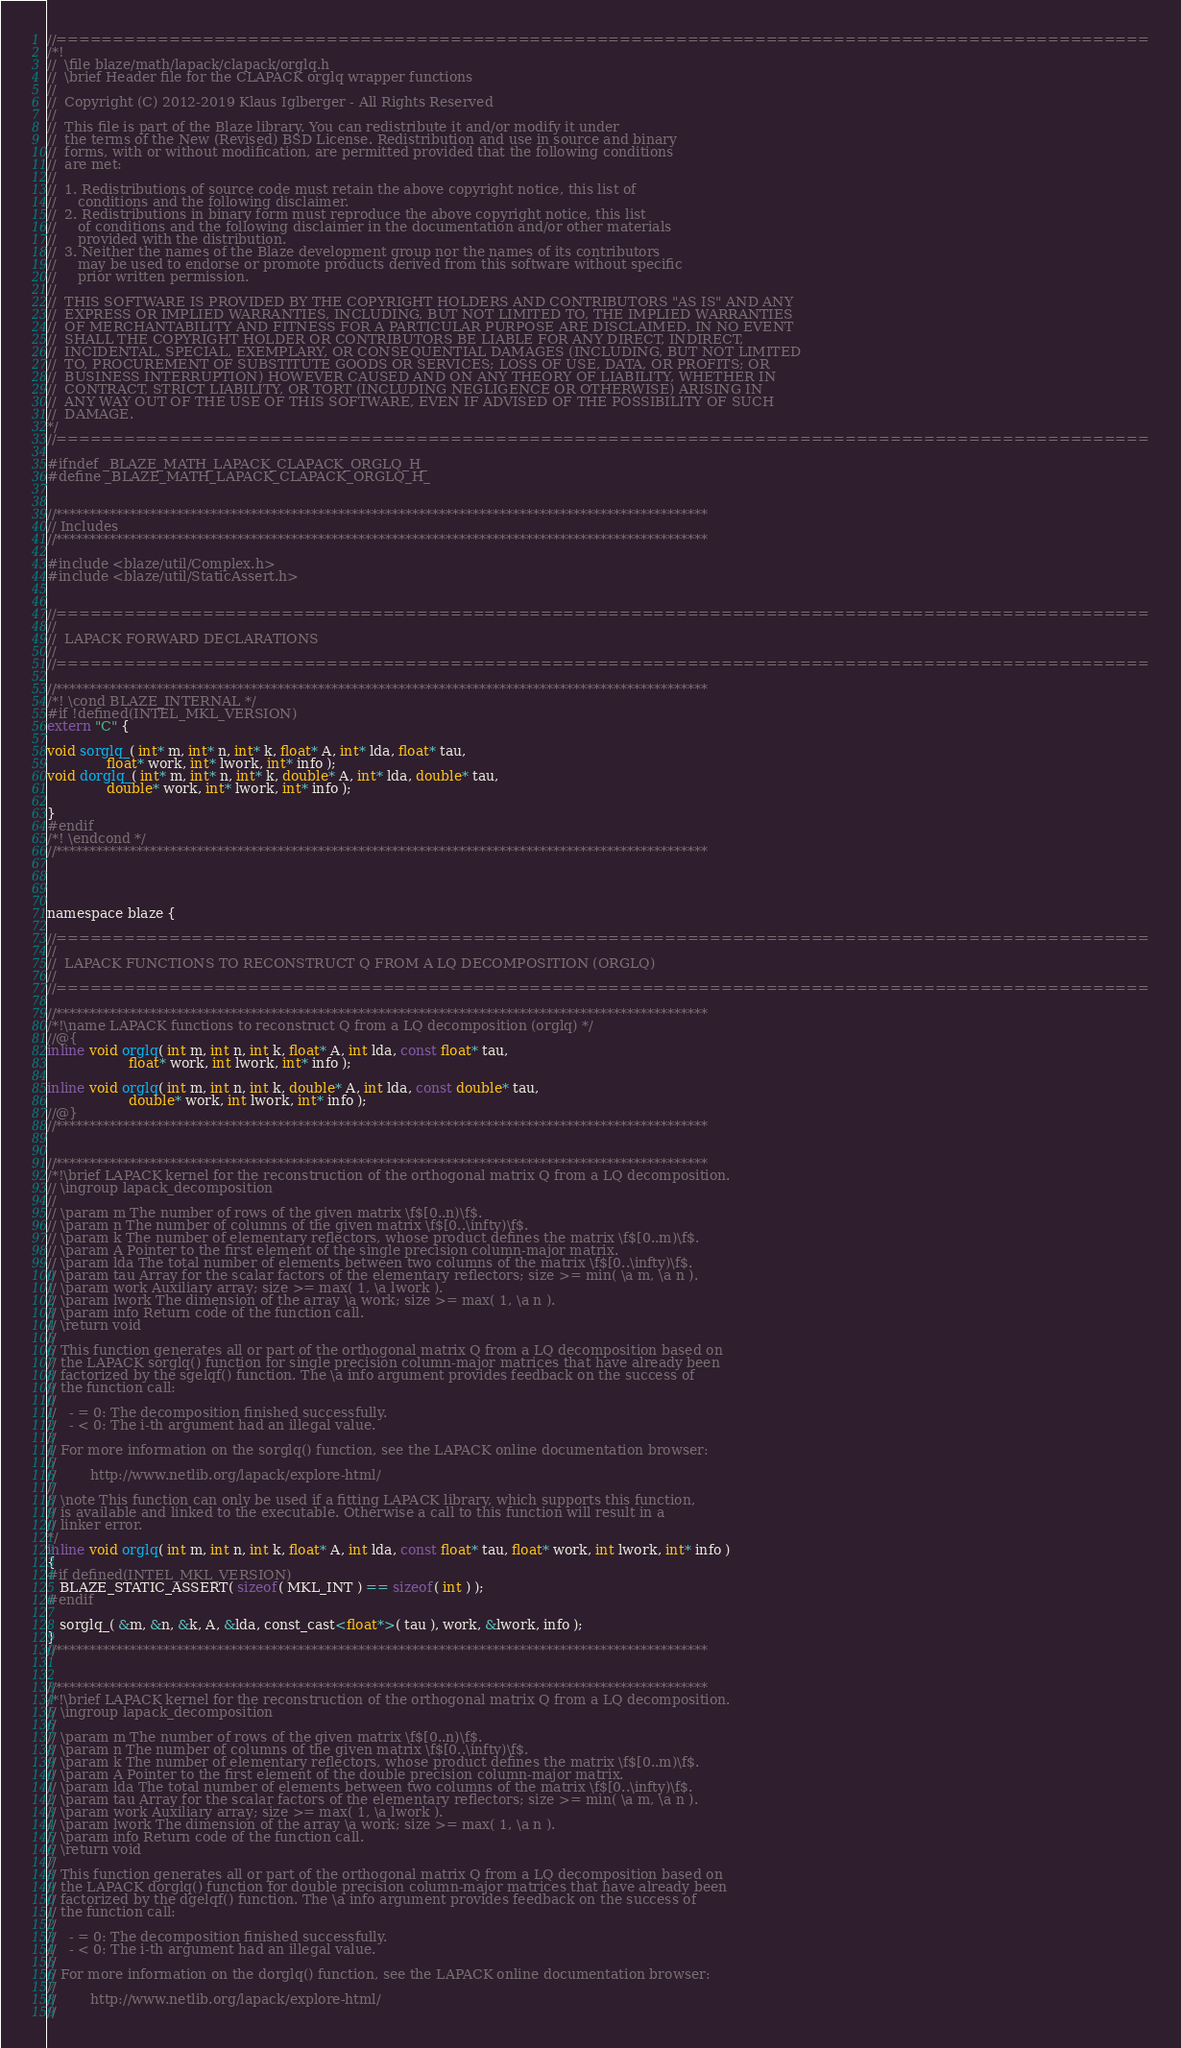<code> <loc_0><loc_0><loc_500><loc_500><_C_>//=================================================================================================
/*!
//  \file blaze/math/lapack/clapack/orglq.h
//  \brief Header file for the CLAPACK orglq wrapper functions
//
//  Copyright (C) 2012-2019 Klaus Iglberger - All Rights Reserved
//
//  This file is part of the Blaze library. You can redistribute it and/or modify it under
//  the terms of the New (Revised) BSD License. Redistribution and use in source and binary
//  forms, with or without modification, are permitted provided that the following conditions
//  are met:
//
//  1. Redistributions of source code must retain the above copyright notice, this list of
//     conditions and the following disclaimer.
//  2. Redistributions in binary form must reproduce the above copyright notice, this list
//     of conditions and the following disclaimer in the documentation and/or other materials
//     provided with the distribution.
//  3. Neither the names of the Blaze development group nor the names of its contributors
//     may be used to endorse or promote products derived from this software without specific
//     prior written permission.
//
//  THIS SOFTWARE IS PROVIDED BY THE COPYRIGHT HOLDERS AND CONTRIBUTORS "AS IS" AND ANY
//  EXPRESS OR IMPLIED WARRANTIES, INCLUDING, BUT NOT LIMITED TO, THE IMPLIED WARRANTIES
//  OF MERCHANTABILITY AND FITNESS FOR A PARTICULAR PURPOSE ARE DISCLAIMED. IN NO EVENT
//  SHALL THE COPYRIGHT HOLDER OR CONTRIBUTORS BE LIABLE FOR ANY DIRECT, INDIRECT,
//  INCIDENTAL, SPECIAL, EXEMPLARY, OR CONSEQUENTIAL DAMAGES (INCLUDING, BUT NOT LIMITED
//  TO, PROCUREMENT OF SUBSTITUTE GOODS OR SERVICES; LOSS OF USE, DATA, OR PROFITS; OR
//  BUSINESS INTERRUPTION) HOWEVER CAUSED AND ON ANY THEORY OF LIABILITY, WHETHER IN
//  CONTRACT, STRICT LIABILITY, OR TORT (INCLUDING NEGLIGENCE OR OTHERWISE) ARISING IN
//  ANY WAY OUT OF THE USE OF THIS SOFTWARE, EVEN IF ADVISED OF THE POSSIBILITY OF SUCH
//  DAMAGE.
*/
//=================================================================================================

#ifndef _BLAZE_MATH_LAPACK_CLAPACK_ORGLQ_H_
#define _BLAZE_MATH_LAPACK_CLAPACK_ORGLQ_H_


//*************************************************************************************************
// Includes
//*************************************************************************************************

#include <blaze/util/Complex.h>
#include <blaze/util/StaticAssert.h>


//=================================================================================================
//
//  LAPACK FORWARD DECLARATIONS
//
//=================================================================================================

//*************************************************************************************************
/*! \cond BLAZE_INTERNAL */
#if !defined(INTEL_MKL_VERSION)
extern "C" {

void sorglq_( int* m, int* n, int* k, float* A, int* lda, float* tau,
              float* work, int* lwork, int* info );
void dorglq_( int* m, int* n, int* k, double* A, int* lda, double* tau,
              double* work, int* lwork, int* info );

}
#endif
/*! \endcond */
//*************************************************************************************************




namespace blaze {

//=================================================================================================
//
//  LAPACK FUNCTIONS TO RECONSTRUCT Q FROM A LQ DECOMPOSITION (ORGLQ)
//
//=================================================================================================

//*************************************************************************************************
/*!\name LAPACK functions to reconstruct Q from a LQ decomposition (orglq) */
//@{
inline void orglq( int m, int n, int k, float* A, int lda, const float* tau,
                   float* work, int lwork, int* info );

inline void orglq( int m, int n, int k, double* A, int lda, const double* tau,
                   double* work, int lwork, int* info );
//@}
//*************************************************************************************************


//*************************************************************************************************
/*!\brief LAPACK kernel for the reconstruction of the orthogonal matrix Q from a LQ decomposition.
// \ingroup lapack_decomposition
//
// \param m The number of rows of the given matrix \f$[0..n)\f$.
// \param n The number of columns of the given matrix \f$[0..\infty)\f$.
// \param k The number of elementary reflectors, whose product defines the matrix \f$[0..m)\f$.
// \param A Pointer to the first element of the single precision column-major matrix.
// \param lda The total number of elements between two columns of the matrix \f$[0..\infty)\f$.
// \param tau Array for the scalar factors of the elementary reflectors; size >= min( \a m, \a n ).
// \param work Auxiliary array; size >= max( 1, \a lwork ).
// \param lwork The dimension of the array \a work; size >= max( 1, \a n ).
// \param info Return code of the function call.
// \return void
//
// This function generates all or part of the orthogonal matrix Q from a LQ decomposition based on
// the LAPACK sorglq() function for single precision column-major matrices that have already been
// factorized by the sgelqf() function. The \a info argument provides feedback on the success of
// the function call:
//
//   - = 0: The decomposition finished successfully.
//   - < 0: The i-th argument had an illegal value.
//
// For more information on the sorglq() function, see the LAPACK online documentation browser:
//
//        http://www.netlib.org/lapack/explore-html/
//
// \note This function can only be used if a fitting LAPACK library, which supports this function,
// is available and linked to the executable. Otherwise a call to this function will result in a
// linker error.
*/
inline void orglq( int m, int n, int k, float* A, int lda, const float* tau, float* work, int lwork, int* info )
{
#if defined(INTEL_MKL_VERSION)
   BLAZE_STATIC_ASSERT( sizeof( MKL_INT ) == sizeof( int ) );
#endif

   sorglq_( &m, &n, &k, A, &lda, const_cast<float*>( tau ), work, &lwork, info );
}
//*************************************************************************************************


//*************************************************************************************************
/*!\brief LAPACK kernel for the reconstruction of the orthogonal matrix Q from a LQ decomposition.
// \ingroup lapack_decomposition
//
// \param m The number of rows of the given matrix \f$[0..n)\f$.
// \param n The number of columns of the given matrix \f$[0..\infty)\f$.
// \param k The number of elementary reflectors, whose product defines the matrix \f$[0..m)\f$.
// \param A Pointer to the first element of the double precision column-major matrix.
// \param lda The total number of elements between two columns of the matrix \f$[0..\infty)\f$.
// \param tau Array for the scalar factors of the elementary reflectors; size >= min( \a m, \a n ).
// \param work Auxiliary array; size >= max( 1, \a lwork ).
// \param lwork The dimension of the array \a work; size >= max( 1, \a n ).
// \param info Return code of the function call.
// \return void
//
// This function generates all or part of the orthogonal matrix Q from a LQ decomposition based on
// the LAPACK dorglq() function for double precision column-major matrices that have already been
// factorized by the dgelqf() function. The \a info argument provides feedback on the success of
// the function call:
//
//   - = 0: The decomposition finished successfully.
//   - < 0: The i-th argument had an illegal value.
//
// For more information on the dorglq() function, see the LAPACK online documentation browser:
//
//        http://www.netlib.org/lapack/explore-html/
//</code> 